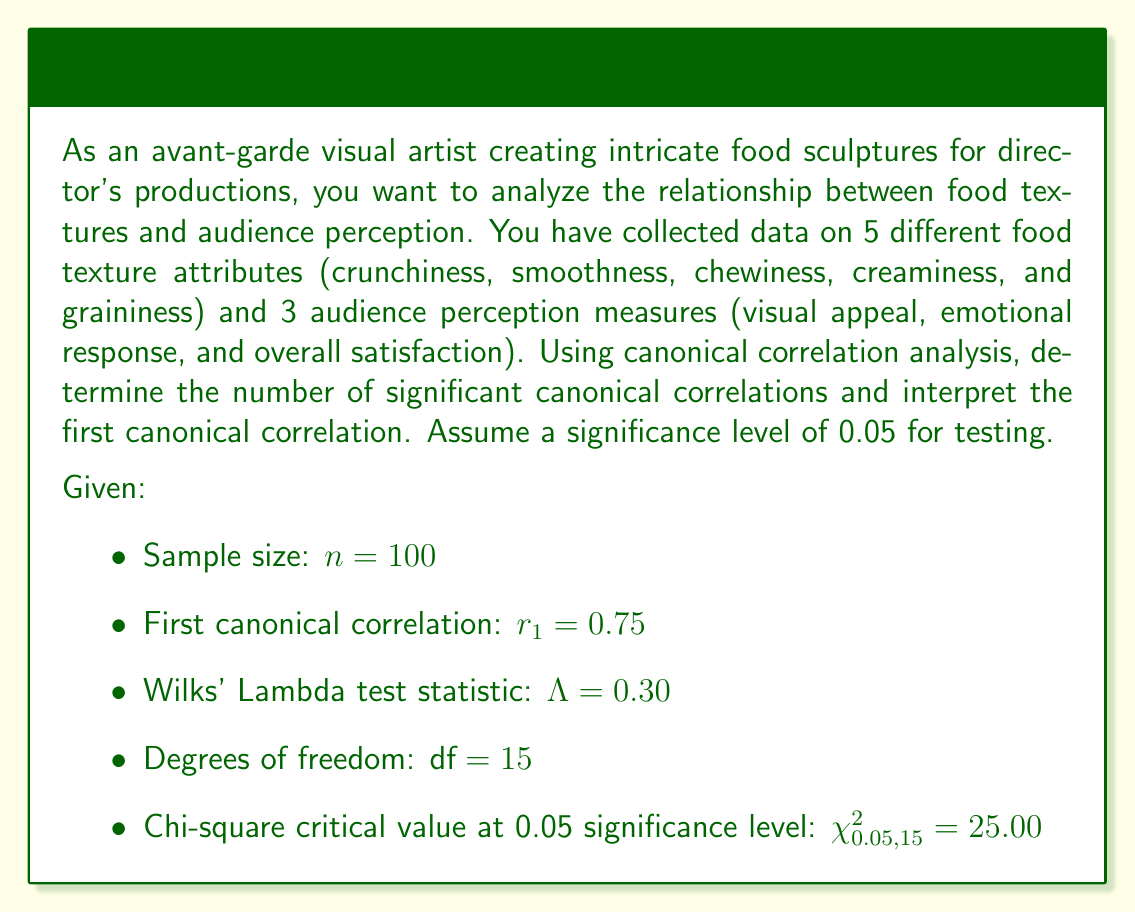Can you answer this question? To solve this problem, we'll follow these steps:

1. Test the significance of all canonical correlations using Wilks' Lambda.
2. Determine the number of significant canonical correlations.
3. Interpret the first canonical correlation.

Step 1: Test the significance of all canonical correlations

Wilks' Lambda is used to test the null hypothesis that all canonical correlations are zero. The test statistic is given as:

$$ \Lambda = \prod_{i=1}^p (1 - r_i^2) $$

where $p$ is the number of canonical correlations, and $r_i$ is the i-th canonical correlation.

We can transform Wilks' Lambda to a chi-square statistic:

$$ \chi^2 = -[n - 1 - \frac{1}{2}(p + q + 1)] \ln(\Lambda) $$

where n is the sample size, p is the number of variables in the first set, and q is the number of variables in the second set.

Given:
$\Lambda = 0.30$
$n = 100$
$p = 5$ (food texture attributes)
$q = 3$ (audience perception measures)

$$ \chi^2 = -[100 - 1 - \frac{1}{2}(5 + 3 + 1)] \ln(0.30) $$
$$ \chi^2 = -95.5 \ln(0.30) $$
$$ \chi^2 = 115.47 $$

The calculated chi-square value (115.47) is greater than the critical value (25.00), so we reject the null hypothesis.

Step 2: Determine the number of significant canonical correlations

Since the overall test is significant, we can conclude that at least one canonical correlation is significant. To determine the exact number, we would need to perform additional tests for each canonical correlation. However, with the given information, we can only confirm that at least one is significant.

Step 3: Interpret the first canonical correlation

The first canonical correlation is $r_1 = 0.75$. This value represents the strength of the relationship between the first pair of canonical variates (linear combinations of food texture attributes and audience perception measures).

To interpret this:

1. Square the canonical correlation: $r_1^2 = 0.75^2 = 0.5625$
2. This means that 56.25% of the variance in the first canonical variate of audience perception measures is explained by the first canonical variate of food texture attributes, and vice versa.

In the context of food sculptures, this suggests a strong relationship between certain combinations of food textures and audience perceptions. For example, a specific combination of crunchiness, smoothness, and creaminess might be strongly associated with high visual appeal and positive emotional response.
Answer: At least one canonical correlation is significant at the 0.05 level. The first canonical correlation of 0.75 indicates a strong relationship between food textures and audience perception, with 56.25% shared variance between the first pair of canonical variates. 